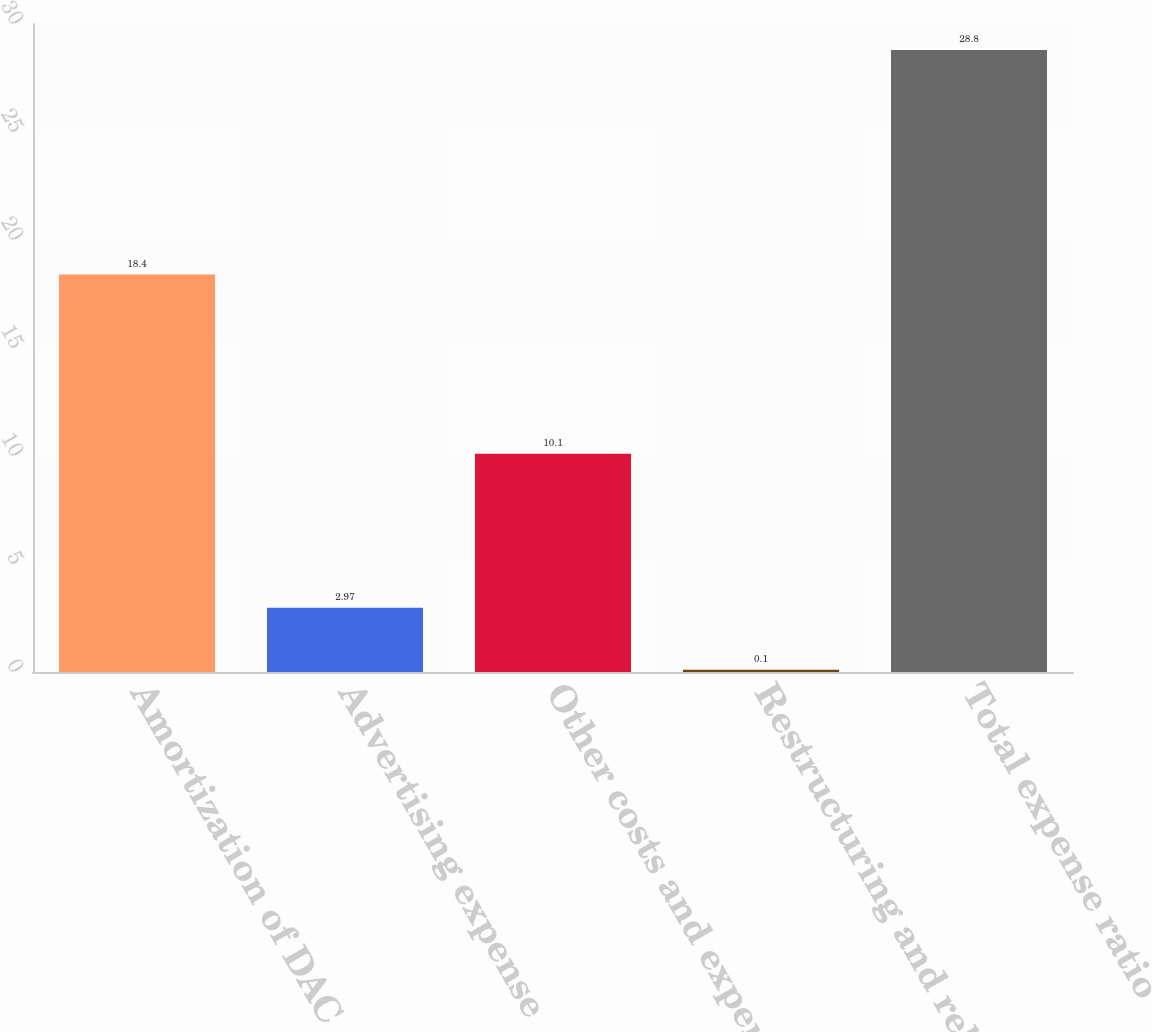Convert chart to OTSL. <chart><loc_0><loc_0><loc_500><loc_500><bar_chart><fcel>Amortization of DAC<fcel>Advertising expense<fcel>Other costs and expenses (1)<fcel>Restructuring and related<fcel>Total expense ratio<nl><fcel>18.4<fcel>2.97<fcel>10.1<fcel>0.1<fcel>28.8<nl></chart> 